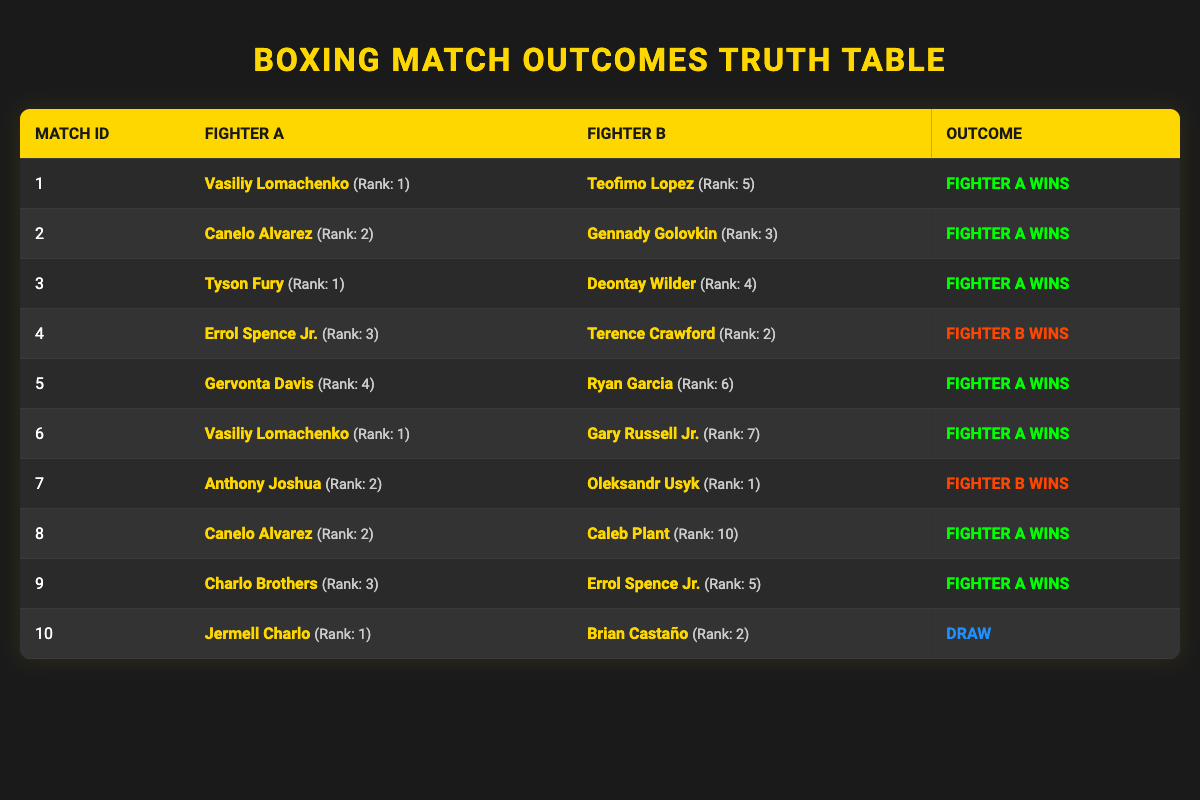What is the outcome of the match between Vasiliy Lomachenko and Teofimo Lopez? The table shows that for match ID 1, Vasiliy Lomachenko (Rank: 1) faced Teofimo Lopez (Rank: 5), and the outcome was "Fighter A wins."
Answer: Fighter A wins Which fighter had the highest ranking in all the matches listed? By reviewing the rankings in the table, Vasiliy Lomachenko and Tyson Fury both have a ranking of 1; hence they are tied for the highest ranking among the fighters.
Answer: Vasiliy Lomachenko and Tyson Fury Did any fights end in a draw? Looking at the outcomes presented in the table, only the match between Jermell Charlo and Brian Castaño resulted in a "Draw."
Answer: Yes How many matches did Fighter A win? Counting the outcomes for the matches where Fighter A is victorious, we find Fighter A won in matches 1, 2, 3, 5, 6, 8, and 9, totaling 7 wins for Fighter A.
Answer: 7 wins What is the difference in ranking between the fighters in the match with the closest rank? The match between Anthony Joshua (Rank: 2) and Oleksandr Usyk (Rank: 1) has the closest ranks, with a difference of 1 ranking position (2 - 1 = 1).
Answer: 1 In how many matches did Fighter B win against higher-ranked opponents? Checking the data, in match ID 4, Terence Crawford (Rank: 2) defeated Errol Spence Jr. (Rank: 3), indicating that Fighter B won against a higher-ranked opponent. In match ID 7, Oleksandr Usyk (Rank: 1) defeated Anthony Joshua (Rank: 2). Therefore, there are 2 matches where Fighter B won against higher-ranked opponents.
Answer: 2 matches Was there a match between fighters both ranked above 5? The data shows matches involving rankings above 5, specifically match ID 8 where Canelo Alvarez (Rank: 2) fought Caleb Plant (Rank: 10). However, since one fighter was ranked 2, this does not satisfy the condition. Therefore, there were no such matches.
Answer: No What percentage of the total matches resulted in Fighter A victories? There are 10 matches in total; Fighter A won 7 of them. To find the percentage of Fighter A victories, divide the wins by total matches: (7/10) * 100 = 70%.
Answer: 70% List the fighters with a ranking of 1 and their match outcomes. From the table, Vasiliy Lomachenko (Rank: 1) won his matches against Teofimo Lopez and Gary Russell Jr., while Tyson Fury (Rank: 1) also won his match against Deontay Wilder. Therefore, both fighters won their respective matches.
Answer: Both fighters won their matches 